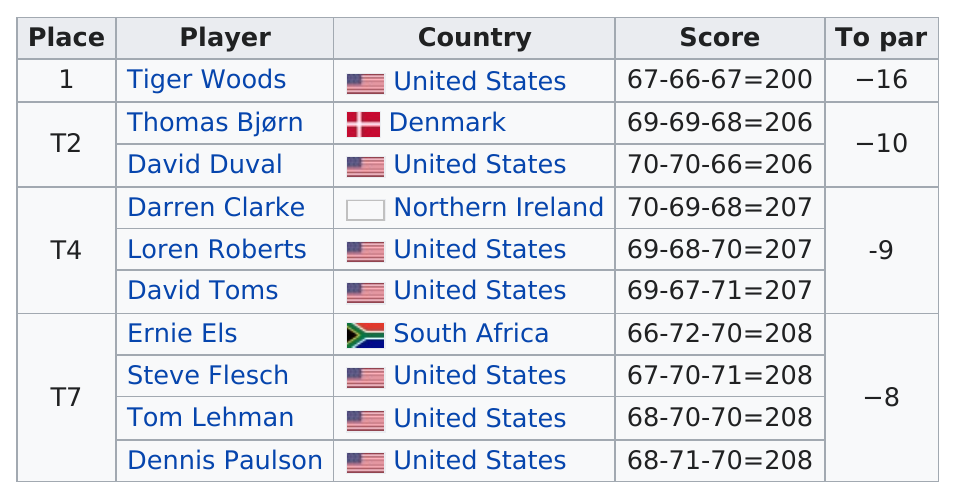Highlight a few significant elements in this photo. There were 7 American players. Only two countries, the United States and Denmark, shot under 206 at the Olympic Games. In his third round, Tiger Woods achieved a score of 67. There are seven players from the United States. Tiger Woods is included in the list 1 time. 